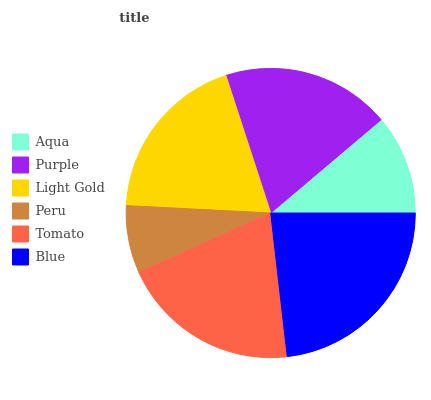Is Peru the minimum?
Answer yes or no. Yes. Is Blue the maximum?
Answer yes or no. Yes. Is Purple the minimum?
Answer yes or no. No. Is Purple the maximum?
Answer yes or no. No. Is Purple greater than Aqua?
Answer yes or no. Yes. Is Aqua less than Purple?
Answer yes or no. Yes. Is Aqua greater than Purple?
Answer yes or no. No. Is Purple less than Aqua?
Answer yes or no. No. Is Light Gold the high median?
Answer yes or no. Yes. Is Purple the low median?
Answer yes or no. Yes. Is Aqua the high median?
Answer yes or no. No. Is Tomato the low median?
Answer yes or no. No. 